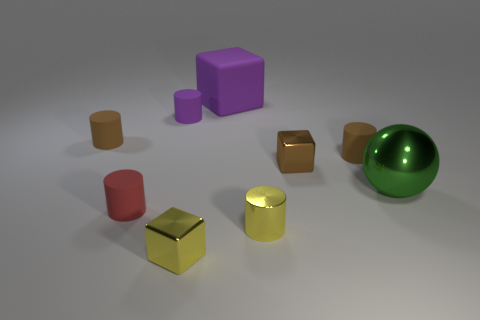What size is the yellow thing that is right of the metallic cube that is in front of the big metal sphere?
Your answer should be compact. Small. What color is the small metal block that is to the left of the large purple matte block?
Offer a terse response. Yellow. There is a cylinder that is made of the same material as the large green ball; what size is it?
Your answer should be very brief. Small. What number of yellow metal objects have the same shape as the large purple matte thing?
Provide a short and direct response. 1. What is the material of the yellow cube that is the same size as the brown metal cube?
Your answer should be compact. Metal. Are there any big objects made of the same material as the red cylinder?
Give a very brief answer. Yes. What color is the cube that is in front of the small purple object and behind the yellow block?
Give a very brief answer. Brown. What number of other objects are there of the same color as the tiny shiny cylinder?
Ensure brevity in your answer.  1. What is the material of the yellow object behind the cube that is left of the rubber thing that is behind the purple matte cylinder?
Make the answer very short. Metal. How many cylinders are tiny purple things or red things?
Provide a short and direct response. 2. 